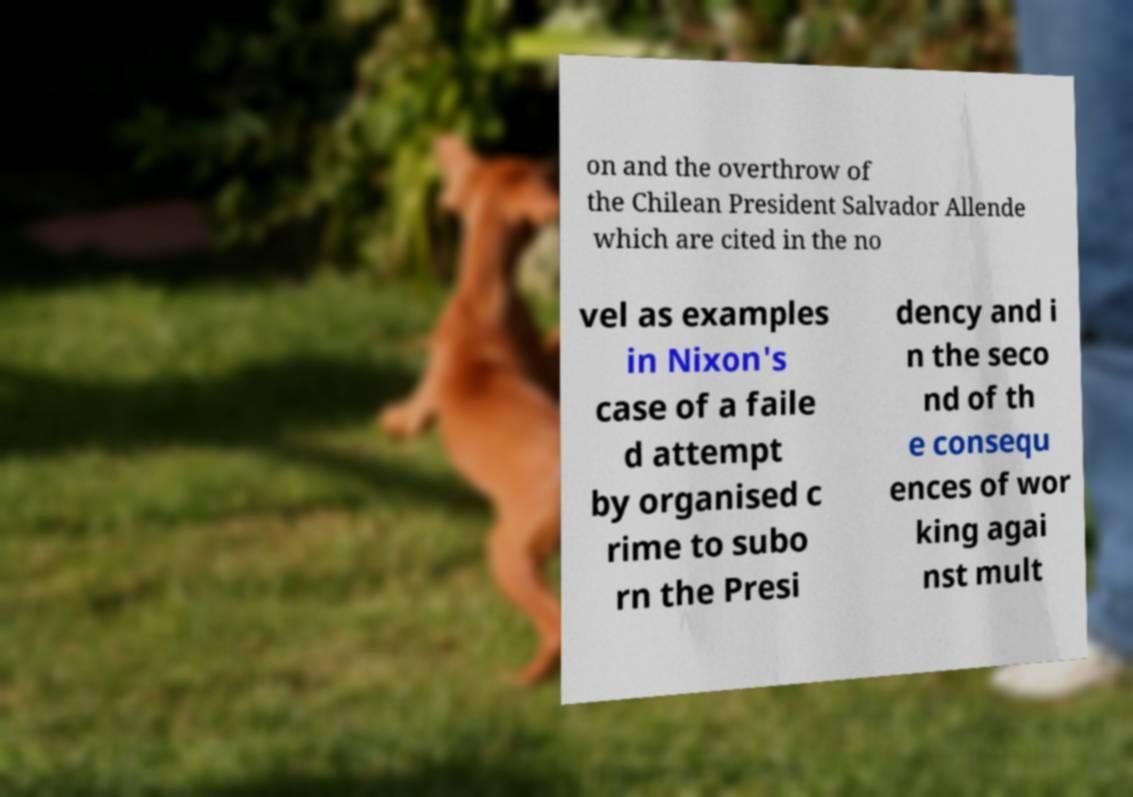What messages or text are displayed in this image? I need them in a readable, typed format. on and the overthrow of the Chilean President Salvador Allende which are cited in the no vel as examples in Nixon's case of a faile d attempt by organised c rime to subo rn the Presi dency and i n the seco nd of th e consequ ences of wor king agai nst mult 